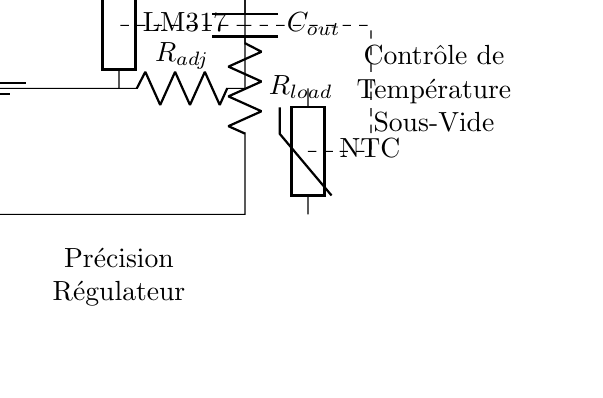What is the input voltage of this circuit? The circuit diagram labels the input voltage as \( V_{in} \), but the specific value is not provided in the diagram itself. Typically, this would be a DC voltage supplied to the regulator.
Answer: \( V_{in} \) What type of regulator is used in this circuit? The circuit explicitly labels the regulator component as "LM317". The LM317 is a popular adjustable linear voltage regulator known for its versatility and precision.
Answer: LM317 What is the purpose of the resistor labeled \( R_{lim} \)? The resistor \( R_{lim} \) is a current-limiting resistor. It helps in protecting the circuit by limiting the maximum current that can flow through the load and the regulator.
Answer: Current-limiting How is temperature feedback implemented in the circuit? The circuit diagram includes a thermistor labeled "NTC", which typically means it's a negative temperature coefficient thermistor. This component is used in the feedback loop to monitor temperature and adjust the output based on temperature changes.
Answer: Feedback loop What is the role of the capacitor labeled \( C_{out} \)? The capacitor \( C_{out} \) is connected at the output of the regulator. It serves to stabilize the voltage and reduce any noise in the output, ensuring a smooth supply to the load.
Answer: Stabilization Which component provides the actual heating in this circuit? The heating element is represented by the resistor \( R_{load} \). It is the component that converts electrical energy into heat for the sous-vide cooking process.
Answer: \( R_{load} \) How does this circuit achieve precise temperature control? Precise temperature control is achieved through the feedback mechanism of the thermistor \( NTC \) and the voltage regulator \( LM317 \). The thermistor senses temperature changes, which adjusts the output, maintaining the desired temperature for sous-vide cooking.
Answer: Feedback with \( NTC \) 